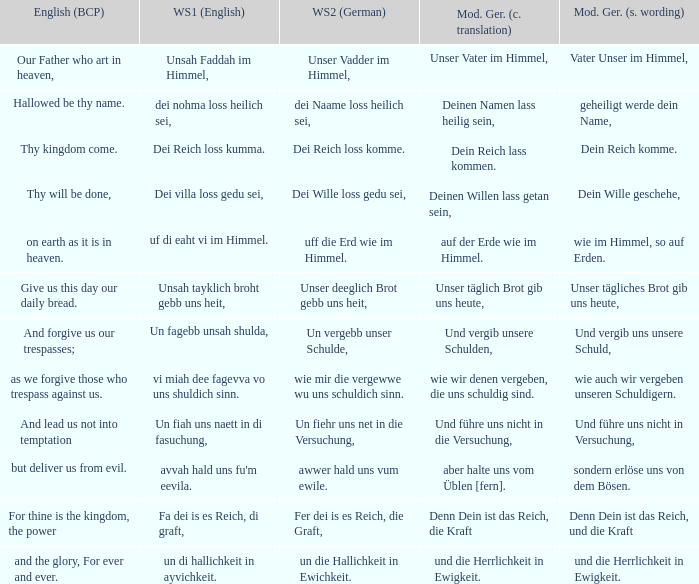What is the english (bcp) phrase "for thine is the kingdom, the power" in modern german with standard wording? Denn Dein ist das Reich, und die Kraft. 